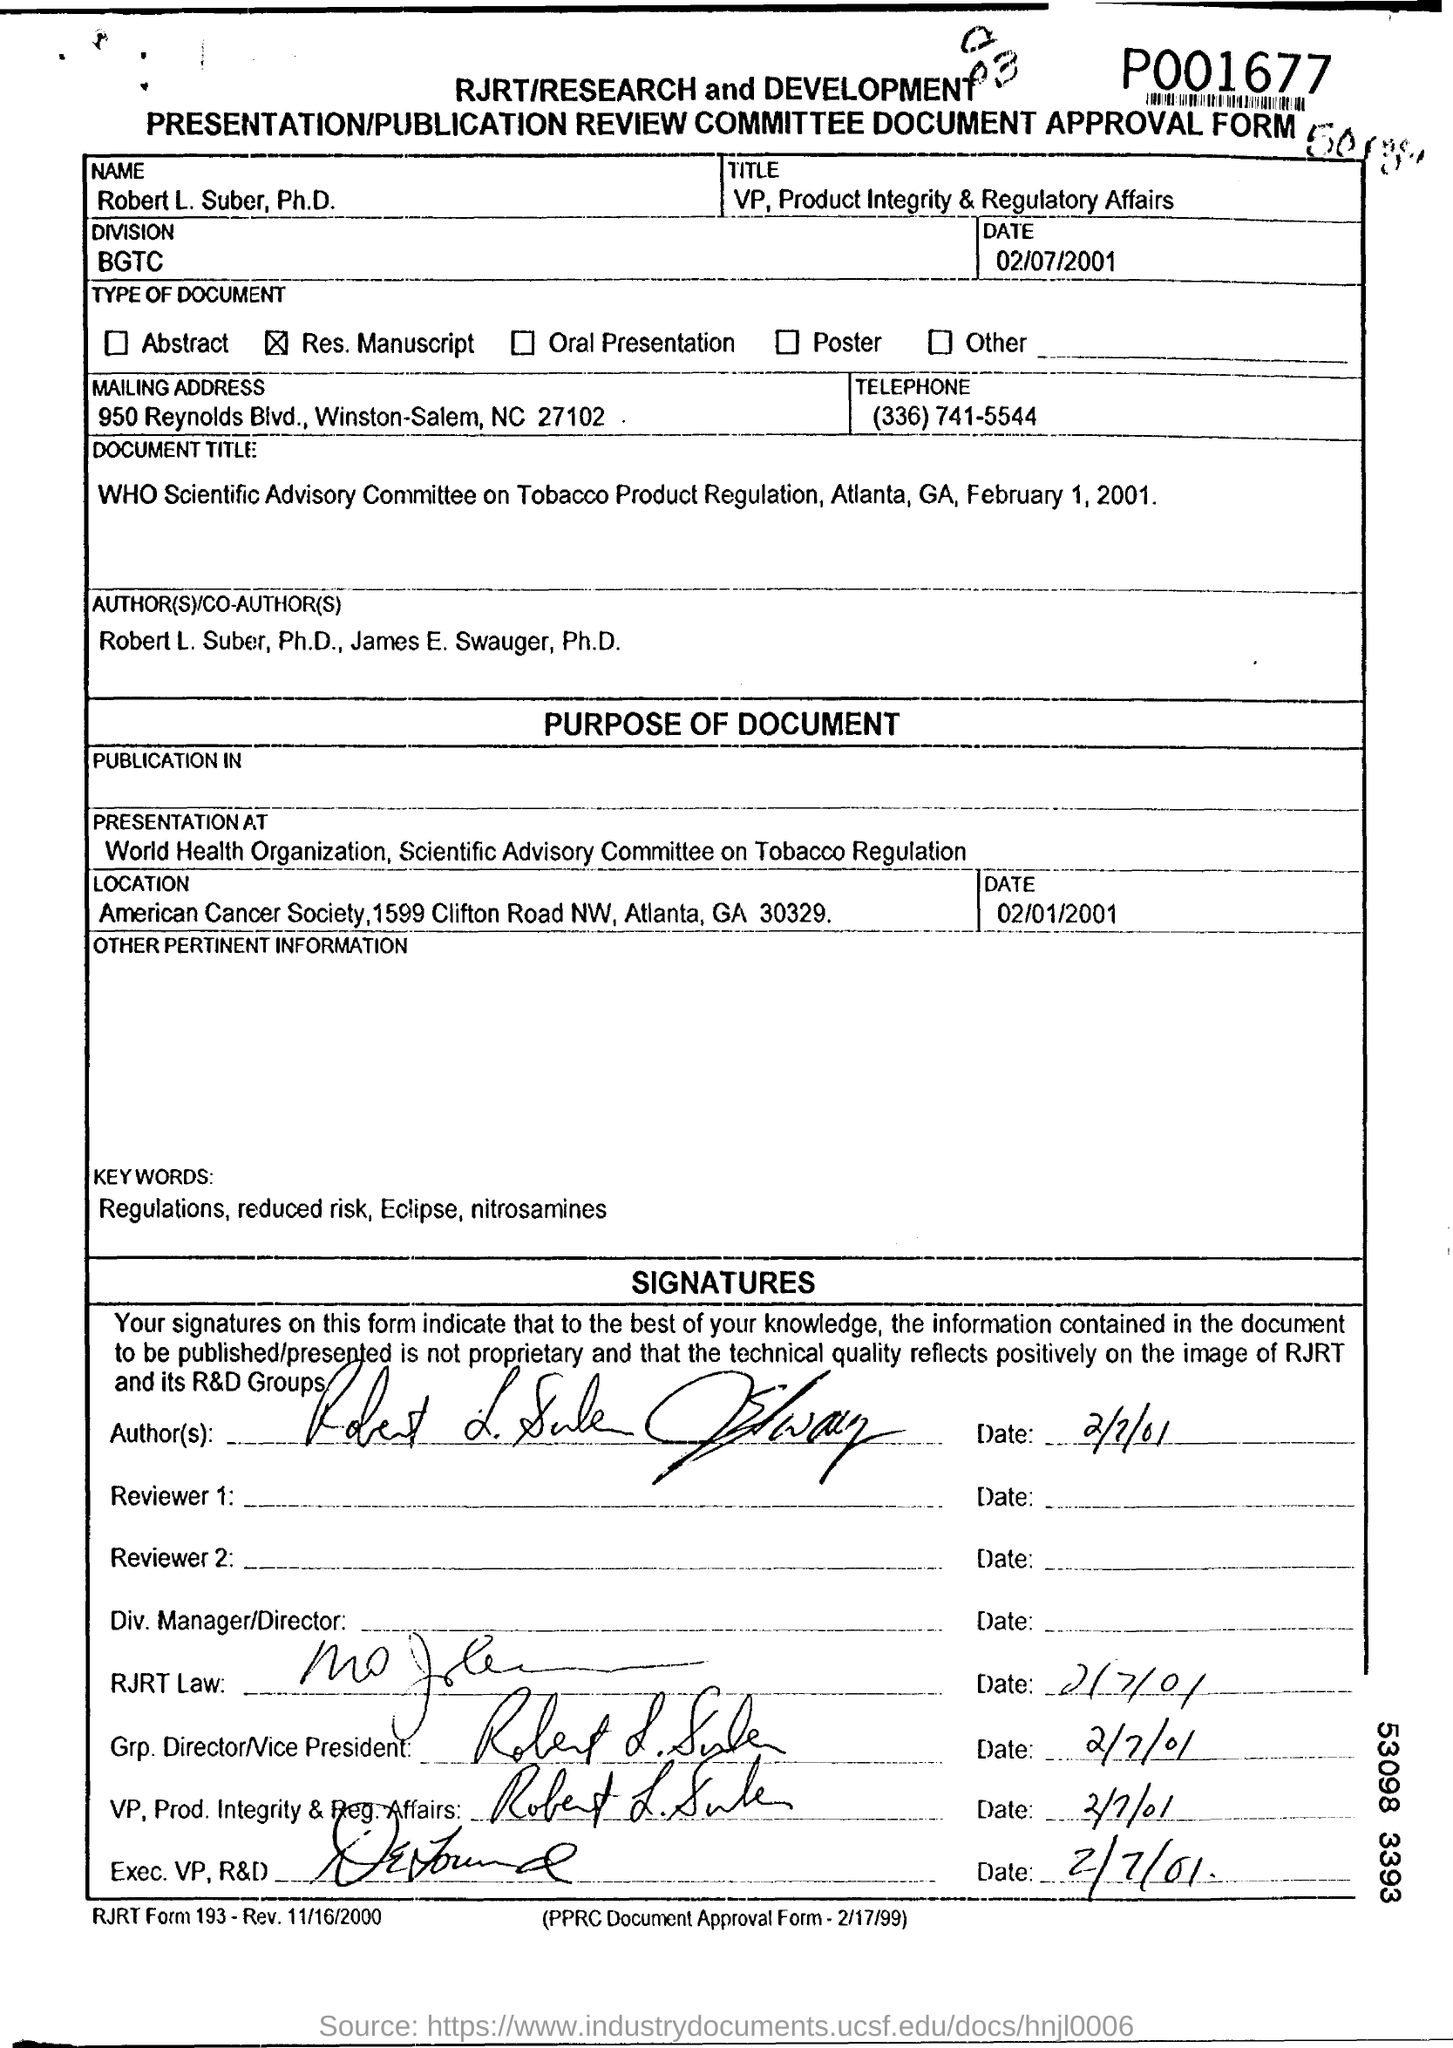Specify some key components in this picture. The date mentioned at the top of the document is February 7, 2001. Robert L. Suber is the Vice President of Product Integrity and Regulatory Affairs. The telephone number is (336) 741-5544. The approval form contains the name "Robert L. Suber. The division field contains the written information 'BGTC.' 